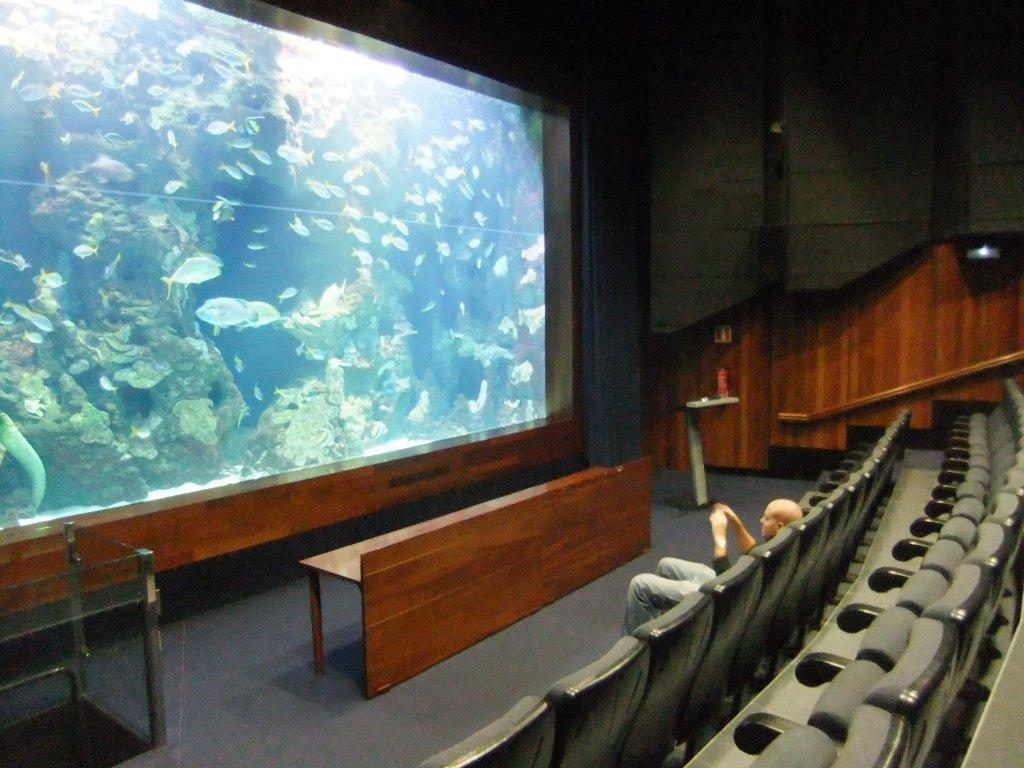How would you summarize this image in a sentence or two? In this image we can see fishes on the screen, here is the wooden table, in front here a man is sitting on the chair, here is the wall. 